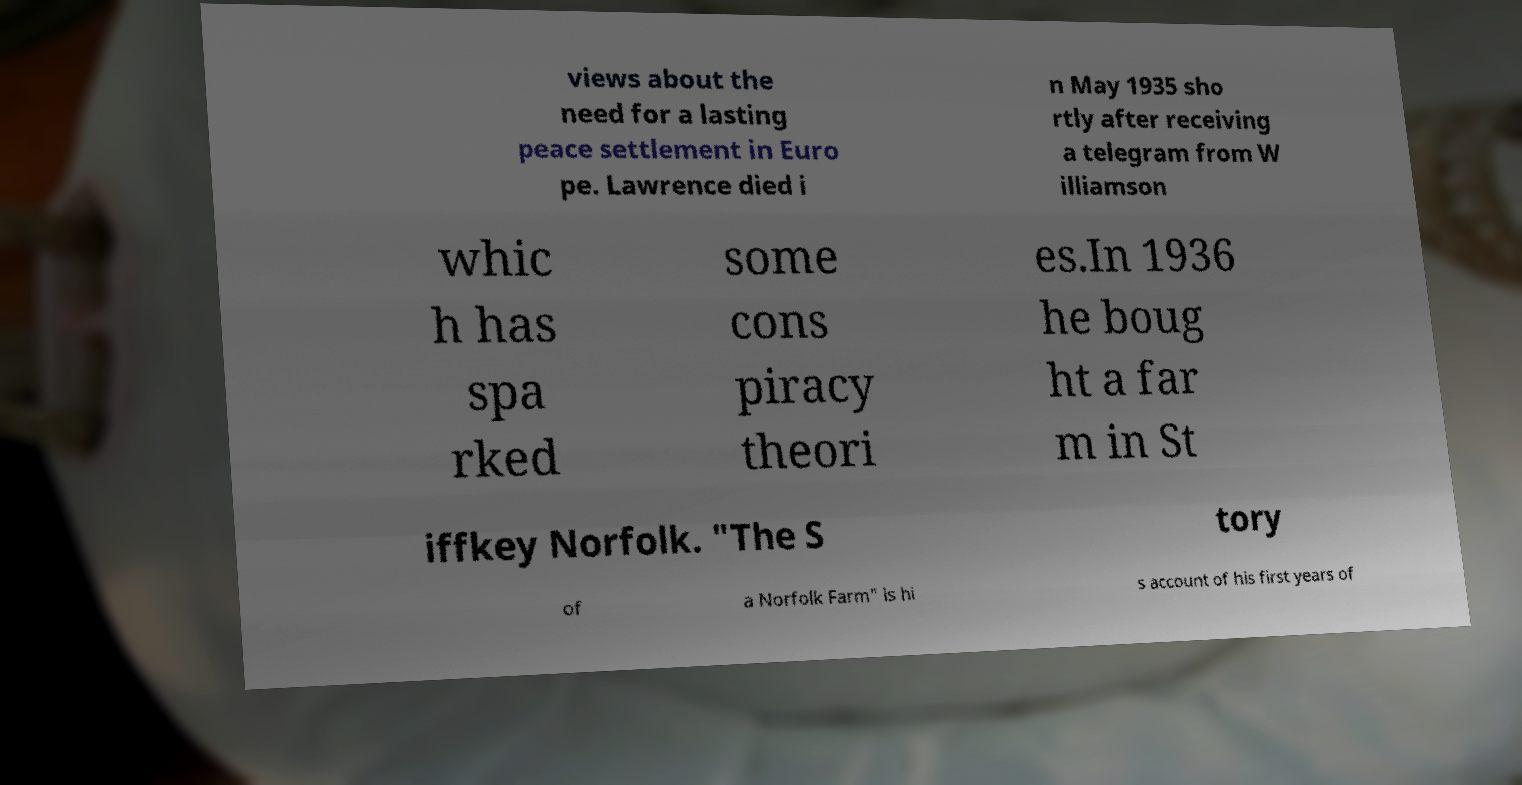Can you read and provide the text displayed in the image?This photo seems to have some interesting text. Can you extract and type it out for me? views about the need for a lasting peace settlement in Euro pe. Lawrence died i n May 1935 sho rtly after receiving a telegram from W illiamson whic h has spa rked some cons piracy theori es.In 1936 he boug ht a far m in St iffkey Norfolk. "The S tory of a Norfolk Farm" is hi s account of his first years of 